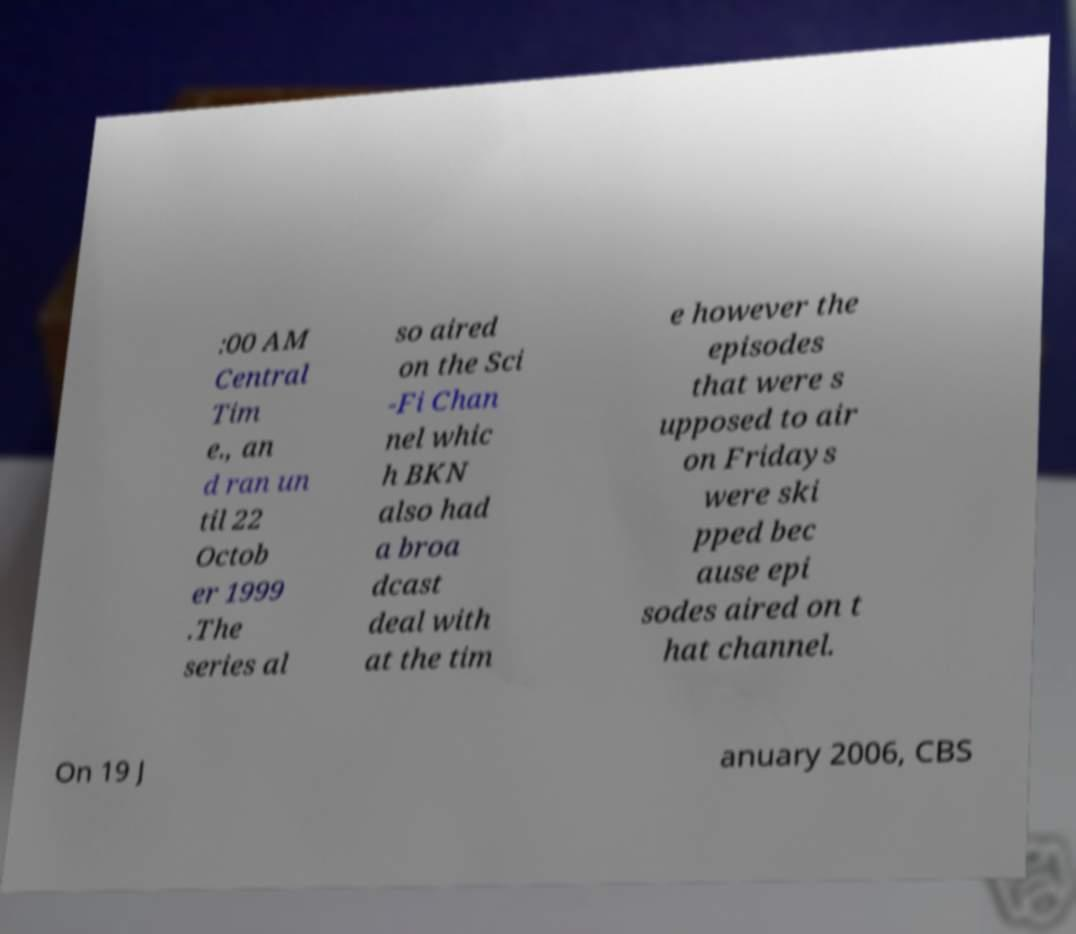Please identify and transcribe the text found in this image. :00 AM Central Tim e., an d ran un til 22 Octob er 1999 .The series al so aired on the Sci -Fi Chan nel whic h BKN also had a broa dcast deal with at the tim e however the episodes that were s upposed to air on Fridays were ski pped bec ause epi sodes aired on t hat channel. On 19 J anuary 2006, CBS 